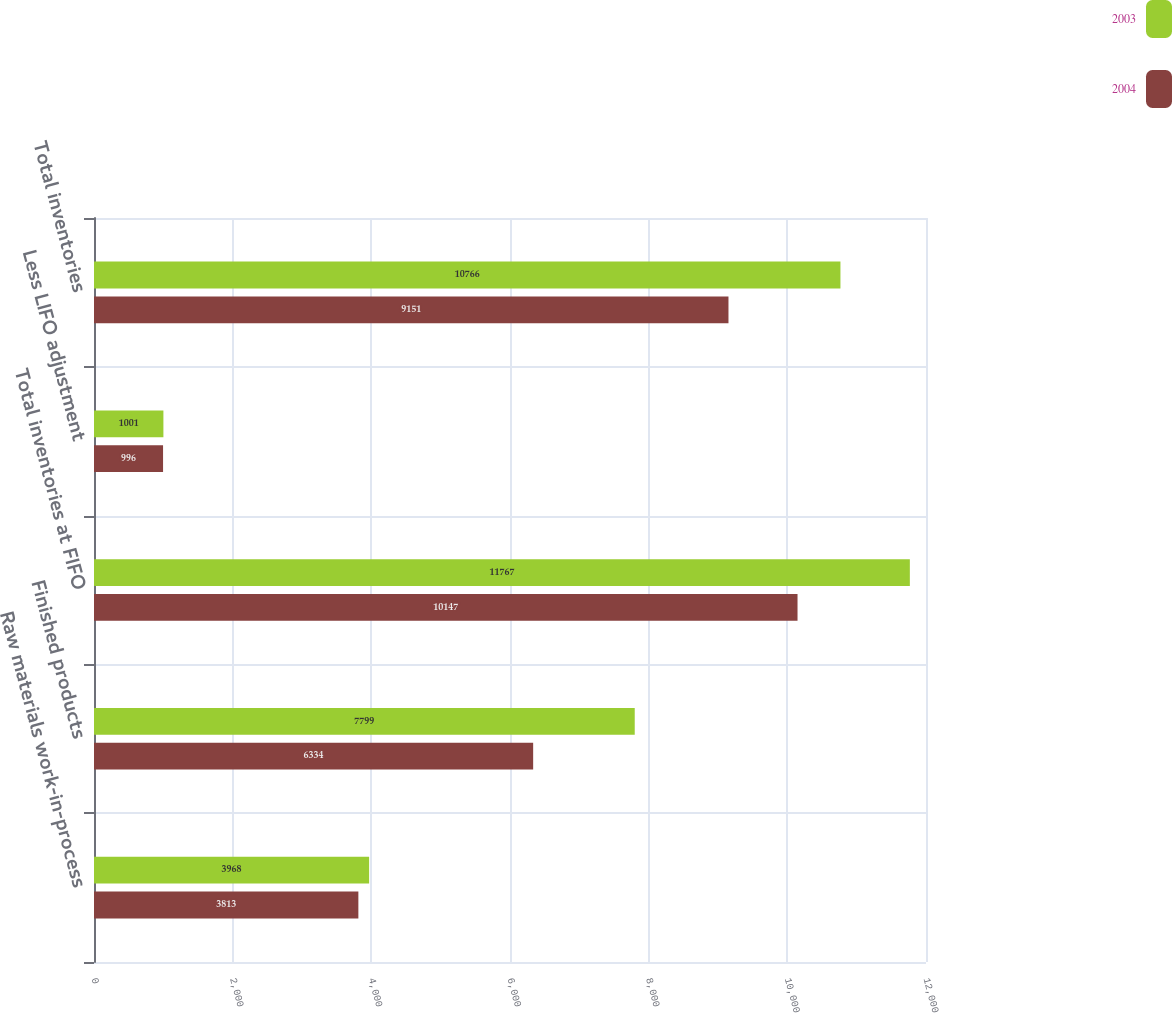Convert chart to OTSL. <chart><loc_0><loc_0><loc_500><loc_500><stacked_bar_chart><ecel><fcel>Raw materials work-in-process<fcel>Finished products<fcel>Total inventories at FIFO<fcel>Less LIFO adjustment<fcel>Total inventories<nl><fcel>2003<fcel>3968<fcel>7799<fcel>11767<fcel>1001<fcel>10766<nl><fcel>2004<fcel>3813<fcel>6334<fcel>10147<fcel>996<fcel>9151<nl></chart> 